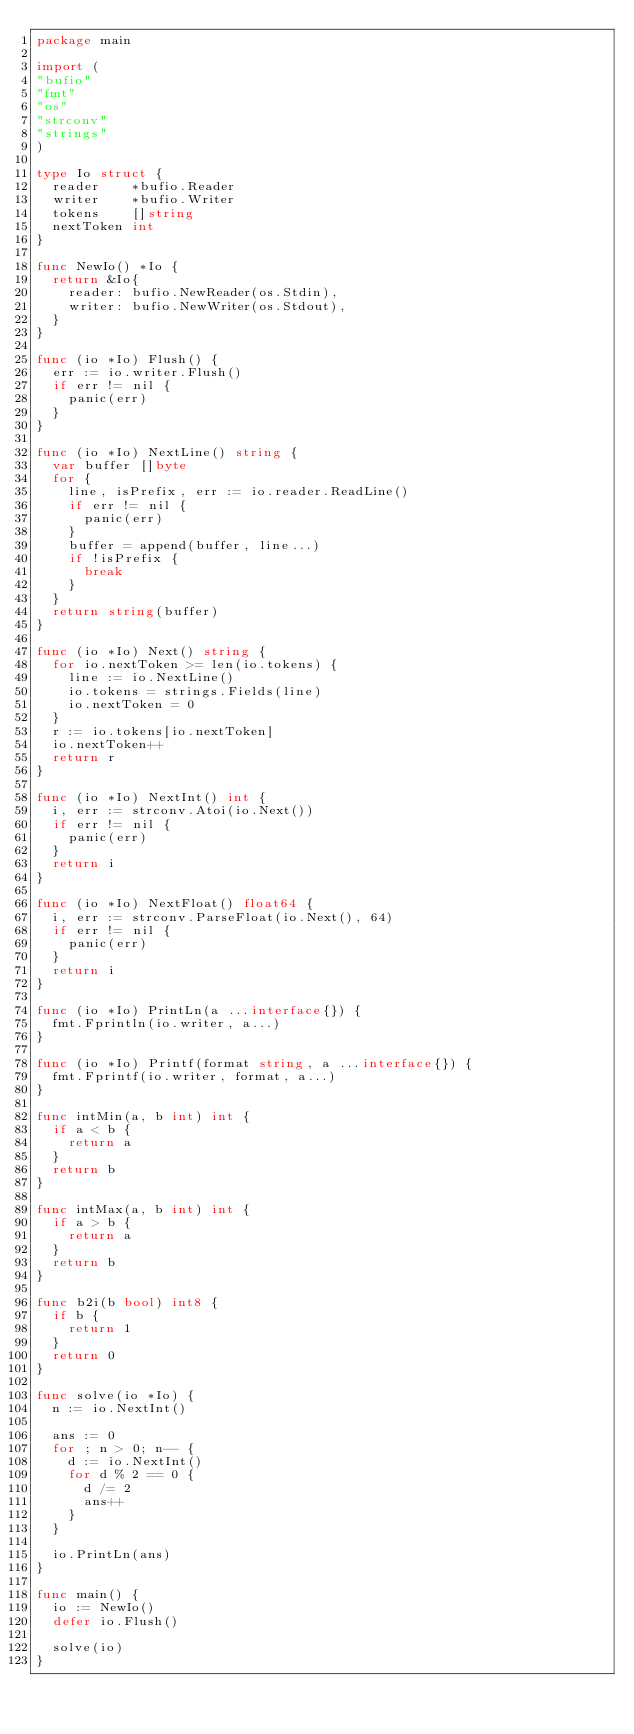<code> <loc_0><loc_0><loc_500><loc_500><_Go_>package main

import (
"bufio"
"fmt"
"os"
"strconv"
"strings"
)

type Io struct {
	reader    *bufio.Reader
	writer    *bufio.Writer
	tokens    []string
	nextToken int
}

func NewIo() *Io {
	return &Io{
		reader: bufio.NewReader(os.Stdin),
		writer: bufio.NewWriter(os.Stdout),
	}
}

func (io *Io) Flush() {
	err := io.writer.Flush()
	if err != nil {
		panic(err)
	}
}

func (io *Io) NextLine() string {
	var buffer []byte
	for {
		line, isPrefix, err := io.reader.ReadLine()
		if err != nil {
			panic(err)
		}
		buffer = append(buffer, line...)
		if !isPrefix {
			break
		}
	}
	return string(buffer)
}

func (io *Io) Next() string {
	for io.nextToken >= len(io.tokens) {
		line := io.NextLine()
		io.tokens = strings.Fields(line)
		io.nextToken = 0
	}
	r := io.tokens[io.nextToken]
	io.nextToken++
	return r
}

func (io *Io) NextInt() int {
	i, err := strconv.Atoi(io.Next())
	if err != nil {
		panic(err)
	}
	return i
}

func (io *Io) NextFloat() float64 {
	i, err := strconv.ParseFloat(io.Next(), 64)
	if err != nil {
		panic(err)
	}
	return i
}

func (io *Io) PrintLn(a ...interface{}) {
	fmt.Fprintln(io.writer, a...)
}

func (io *Io) Printf(format string, a ...interface{}) {
	fmt.Fprintf(io.writer, format, a...)
}

func intMin(a, b int) int {
	if a < b {
		return a
	}
	return b
}

func intMax(a, b int) int {
	if a > b {
		return a
	}
	return b
}

func b2i(b bool) int8 {
	if b {
		return 1
	}
	return 0
}

func solve(io *Io) {
	n := io.NextInt()

	ans := 0
	for ; n > 0; n-- {
		d := io.NextInt()
		for d % 2 == 0 {
			d /= 2
			ans++
		}
	}

	io.PrintLn(ans)
}

func main() {
	io := NewIo()
	defer io.Flush()

	solve(io)
}</code> 